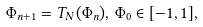<formula> <loc_0><loc_0><loc_500><loc_500>\Phi _ { n + 1 } = T _ { N } ( \Phi _ { n } ) , \, \Phi _ { 0 } \in [ - 1 , 1 ] ,</formula> 